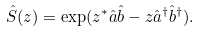Convert formula to latex. <formula><loc_0><loc_0><loc_500><loc_500>\hat { S } ( z ) = \exp ( z ^ { \ast } \hat { a } \hat { b } - z \hat { a } ^ { \dagger } \hat { b } ^ { \dagger } ) .</formula> 